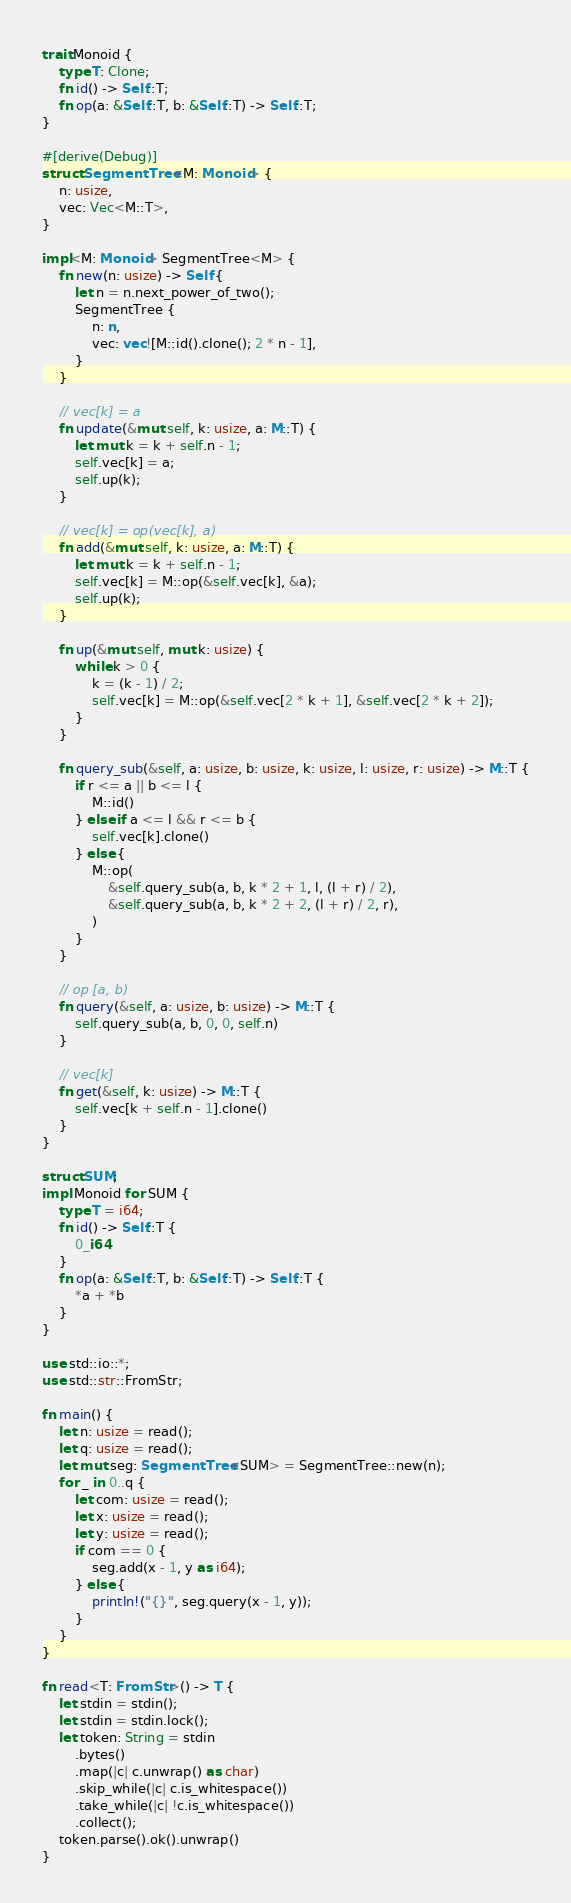Convert code to text. <code><loc_0><loc_0><loc_500><loc_500><_Rust_>trait Monoid {
    type T: Clone;
    fn id() -> Self::T;
    fn op(a: &Self::T, b: &Self::T) -> Self::T;
}

#[derive(Debug)]
struct SegmentTree<M: Monoid> {
    n: usize,
    vec: Vec<M::T>,
}

impl<M: Monoid> SegmentTree<M> {
    fn new(n: usize) -> Self {
        let n = n.next_power_of_two();
        SegmentTree {
            n: n,
            vec: vec![M::id().clone(); 2 * n - 1],
        }
    }

    // vec[k] = a
    fn update(&mut self, k: usize, a: M::T) {
        let mut k = k + self.n - 1;
        self.vec[k] = a;
        self.up(k);
    }

    // vec[k] = op(vec[k], a)
    fn add(&mut self, k: usize, a: M::T) {
        let mut k = k + self.n - 1;
        self.vec[k] = M::op(&self.vec[k], &a);
        self.up(k);
    }

    fn up(&mut self, mut k: usize) {
        while k > 0 {
            k = (k - 1) / 2;
            self.vec[k] = M::op(&self.vec[2 * k + 1], &self.vec[2 * k + 2]);
        }
    }

    fn query_sub(&self, a: usize, b: usize, k: usize, l: usize, r: usize) -> M::T {
        if r <= a || b <= l {
            M::id()
        } else if a <= l && r <= b {
            self.vec[k].clone()
        } else {
            M::op(
                &self.query_sub(a, b, k * 2 + 1, l, (l + r) / 2),
                &self.query_sub(a, b, k * 2 + 2, (l + r) / 2, r),
            )
        }
    }

    // op [a, b)
    fn query(&self, a: usize, b: usize) -> M::T {
        self.query_sub(a, b, 0, 0, self.n)
    }

    // vec[k]
    fn get(&self, k: usize) -> M::T {
        self.vec[k + self.n - 1].clone()
    }
}

struct SUM;
impl Monoid for SUM {
    type T = i64;
    fn id() -> Self::T {
        0_i64
    }
    fn op(a: &Self::T, b: &Self::T) -> Self::T {
        *a + *b
    }
}

use std::io::*;
use std::str::FromStr;

fn main() {
    let n: usize = read();
    let q: usize = read();
    let mut seg: SegmentTree<SUM> = SegmentTree::new(n);
    for _ in 0..q {
        let com: usize = read();
        let x: usize = read();
        let y: usize = read();
        if com == 0 {
            seg.add(x - 1, y as i64);
        } else {
            println!("{}", seg.query(x - 1, y));
        }
    }
}

fn read<T: FromStr>() -> T {
    let stdin = stdin();
    let stdin = stdin.lock();
    let token: String = stdin
        .bytes()
        .map(|c| c.unwrap() as char)
        .skip_while(|c| c.is_whitespace())
        .take_while(|c| !c.is_whitespace())
        .collect();
    token.parse().ok().unwrap()
}

</code> 